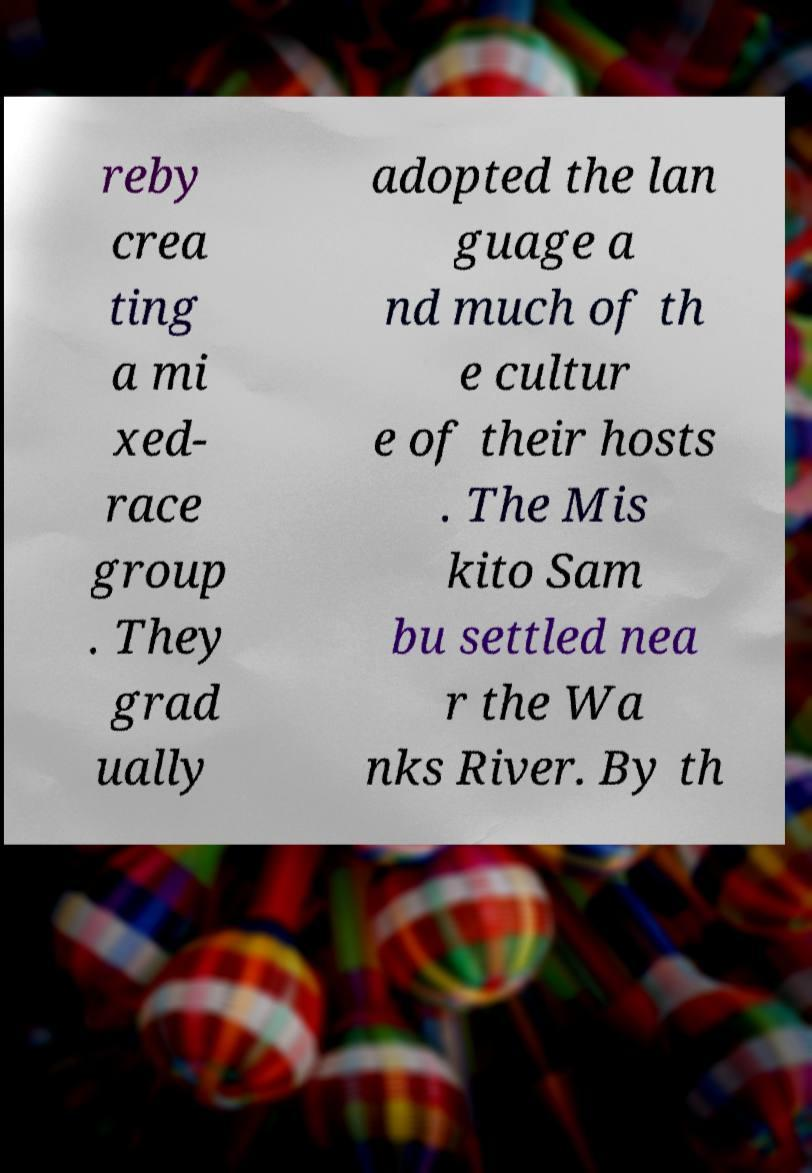There's text embedded in this image that I need extracted. Can you transcribe it verbatim? reby crea ting a mi xed- race group . They grad ually adopted the lan guage a nd much of th e cultur e of their hosts . The Mis kito Sam bu settled nea r the Wa nks River. By th 